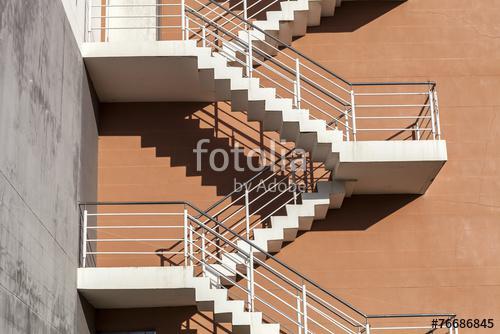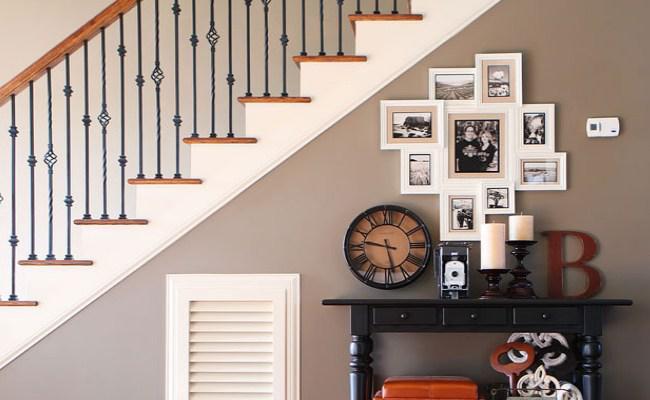The first image is the image on the left, the second image is the image on the right. Evaluate the accuracy of this statement regarding the images: "One staircase has a white side edge and descends without turns midway, and the other staircase has zig-zag turns.". Is it true? Answer yes or no. Yes. The first image is the image on the left, the second image is the image on the right. For the images shown, is this caption "All the stairs go in at least two directions." true? Answer yes or no. No. 